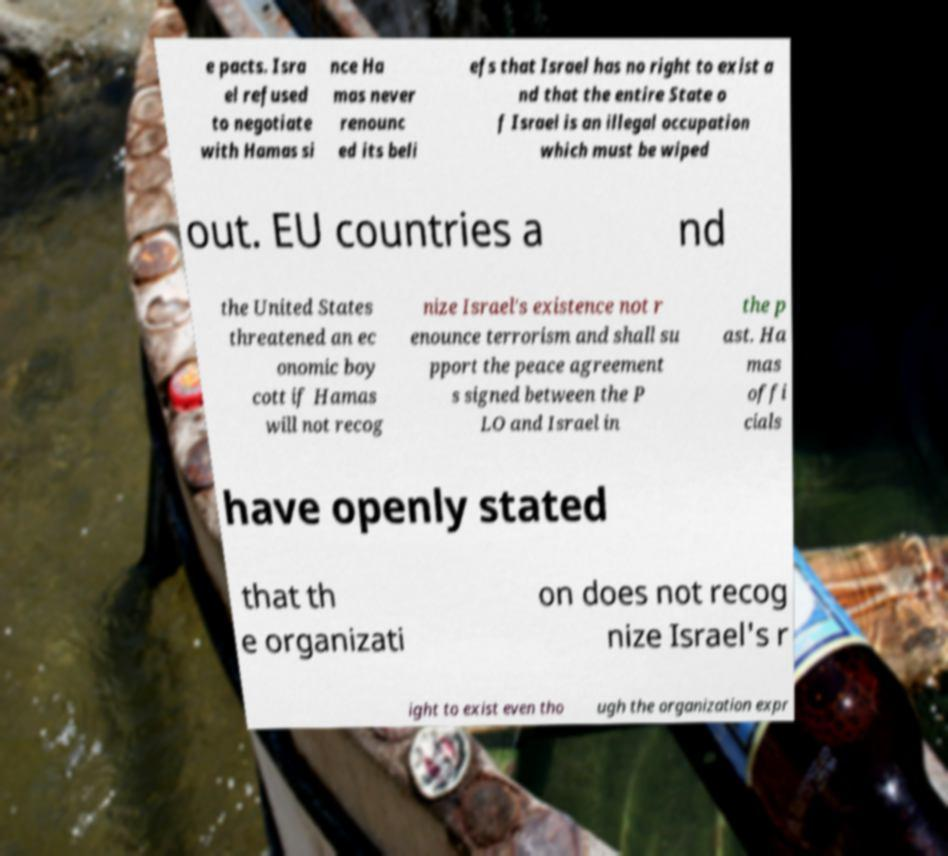What messages or text are displayed in this image? I need them in a readable, typed format. e pacts. Isra el refused to negotiate with Hamas si nce Ha mas never renounc ed its beli efs that Israel has no right to exist a nd that the entire State o f Israel is an illegal occupation which must be wiped out. EU countries a nd the United States threatened an ec onomic boy cott if Hamas will not recog nize Israel's existence not r enounce terrorism and shall su pport the peace agreement s signed between the P LO and Israel in the p ast. Ha mas offi cials have openly stated that th e organizati on does not recog nize Israel's r ight to exist even tho ugh the organization expr 